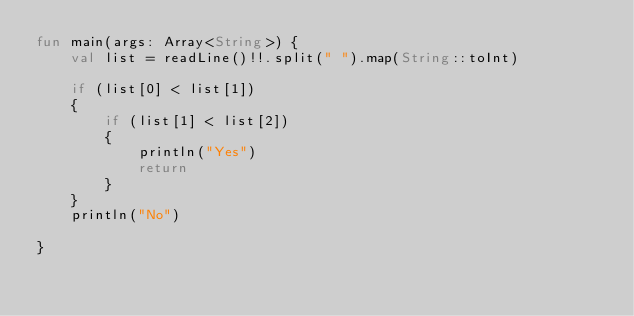Convert code to text. <code><loc_0><loc_0><loc_500><loc_500><_Kotlin_>fun main(args: Array<String>) {
    val list = readLine()!!.split(" ").map(String::toInt)

    if (list[0] < list[1])
    {
        if (list[1] < list[2])
        {
            println("Yes")
            return
        }
    }
    println("No")

}
</code> 